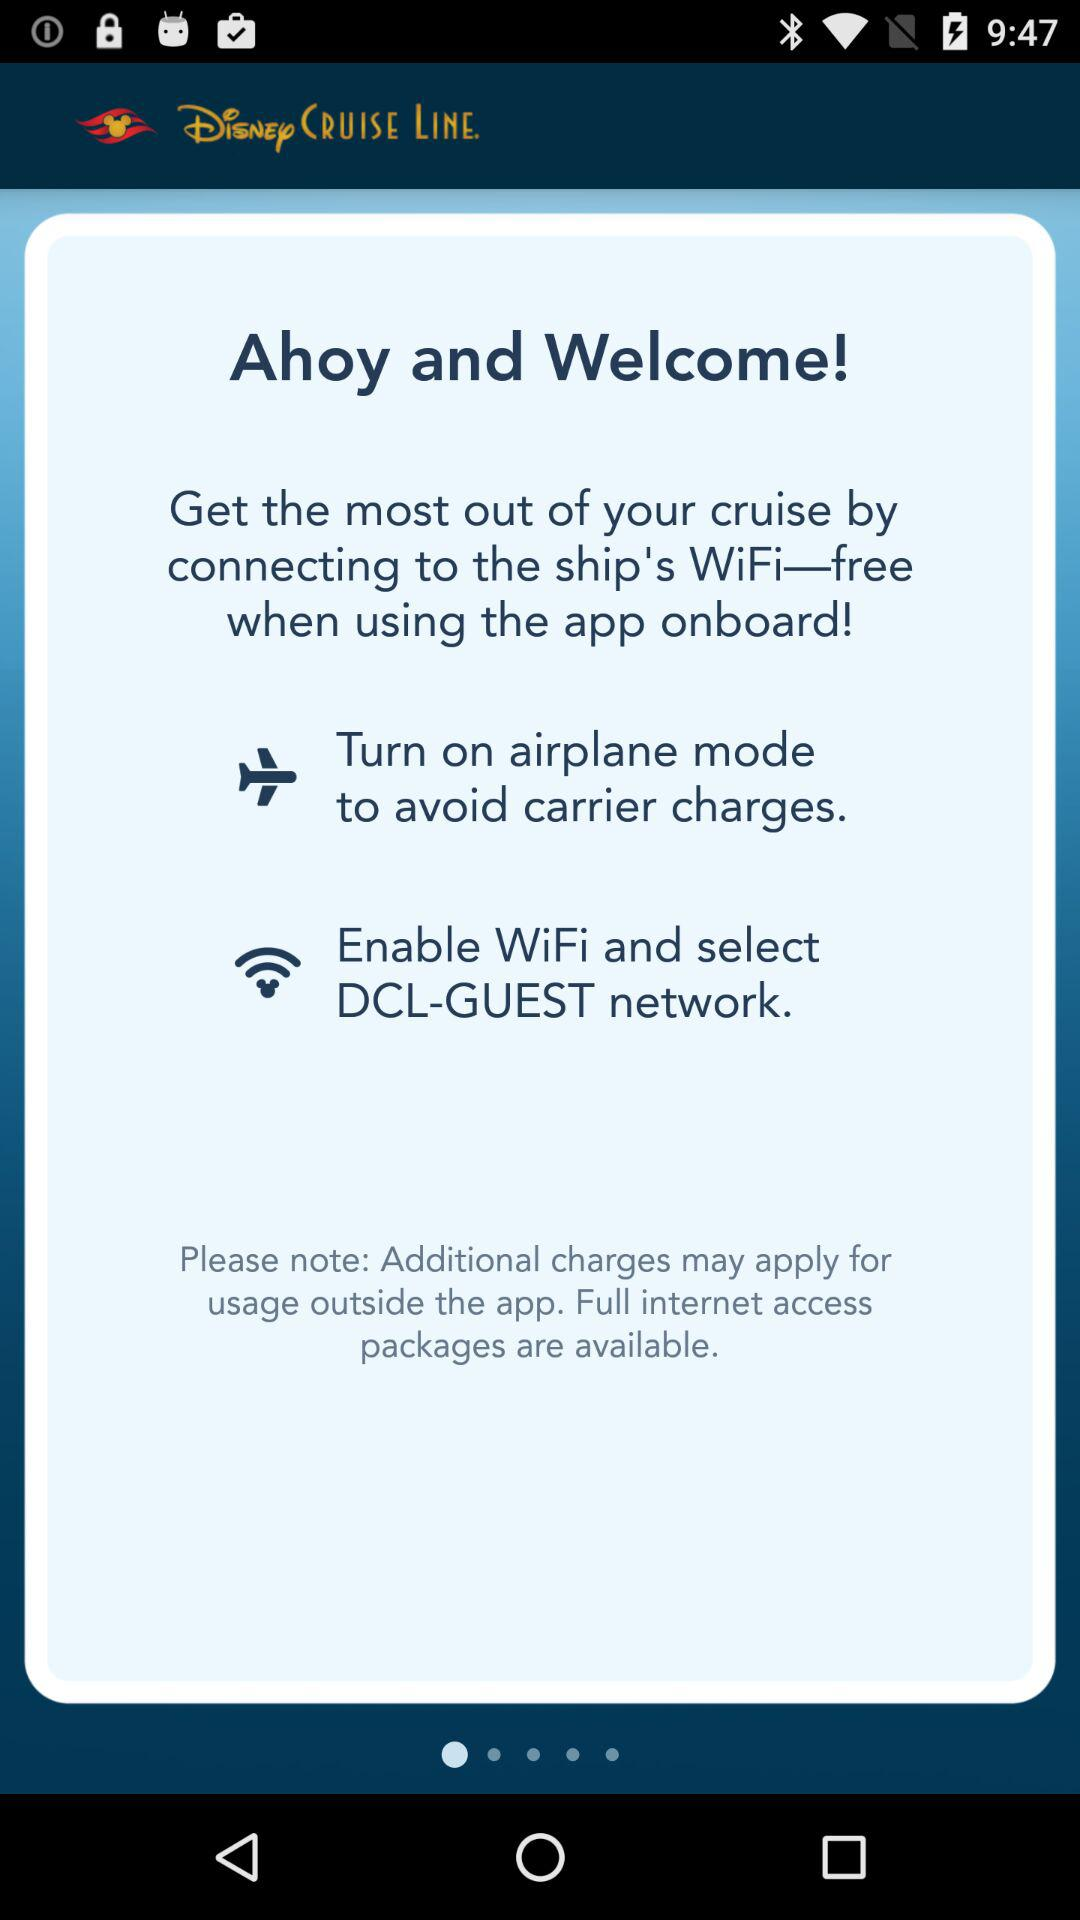How many more steps do I need to take to enable WiFi?
Answer the question using a single word or phrase. 2 